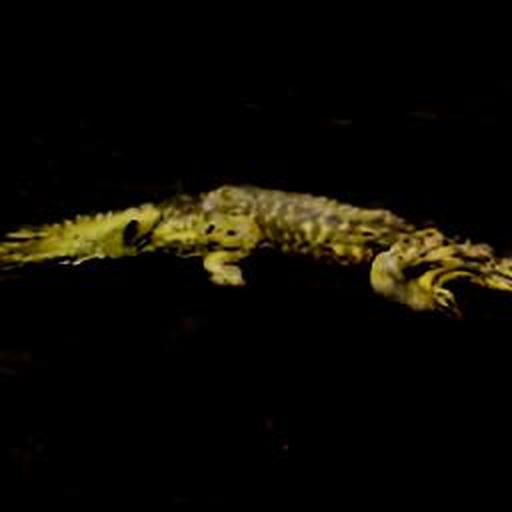What can you say about the composition of the image? The composition of the image seems intentional but falls short of being perfectly aligned or symmetrical. The subject, which appears to be a crocodile, is partially obscured by shadows, giving a mysterious and slightly eerie effect. This could be seen as visually appealing to some due to its dramatic ambiance; however, the image is not well-balanced, with the focus being off-center and the angle slightly tilted, creating a sense of unease. In conclusion, the composition aims to evoke a particular mood rather than adhere strictly to conventional aesthetic standards. 